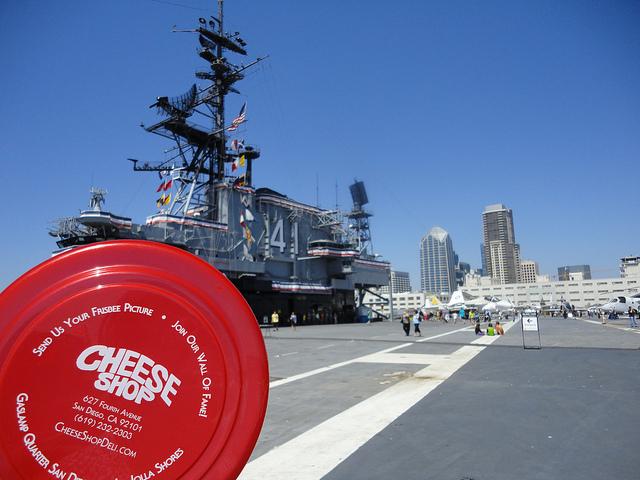What business is on the red disk?
Write a very short answer. Cheese shop. Is the ship in the ocean?
Quick response, please. No. What numbers are on the ship?
Short answer required. 41. 